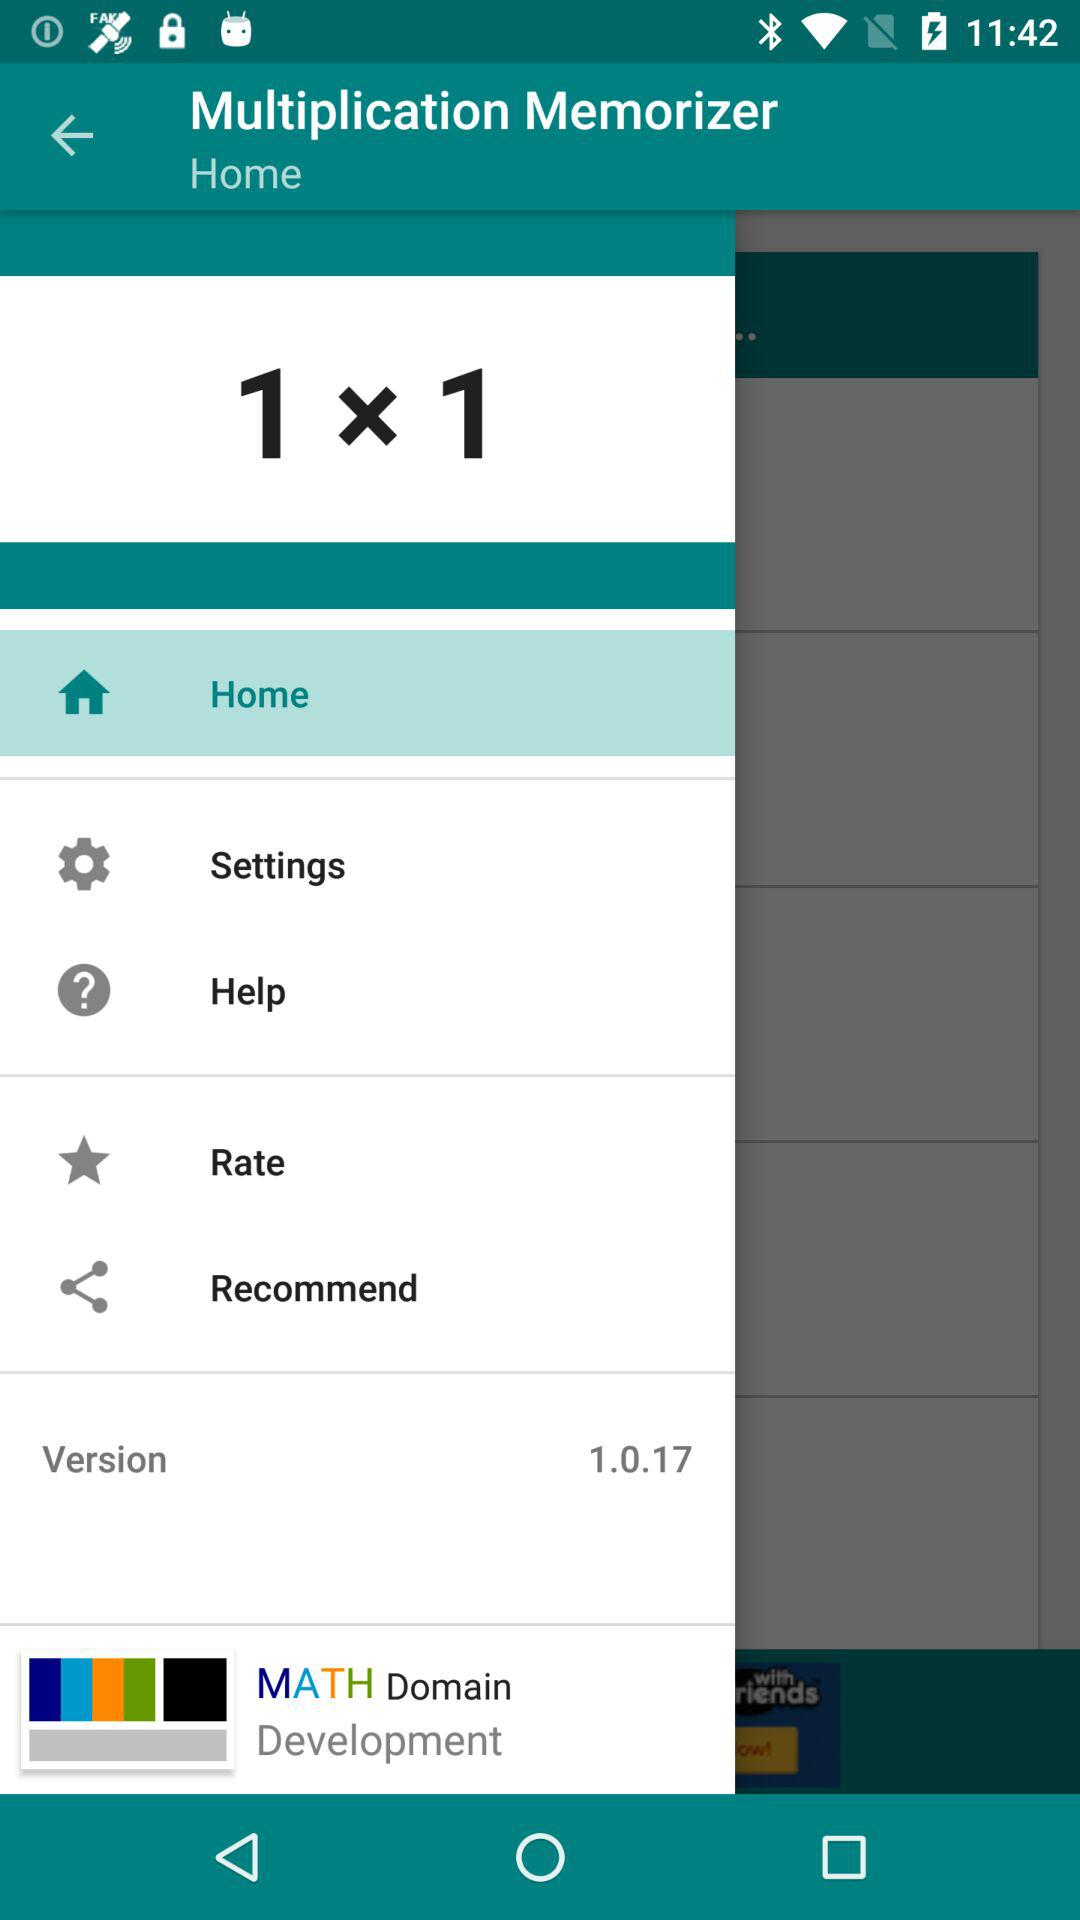What is the version? The version is 1.0.17. 